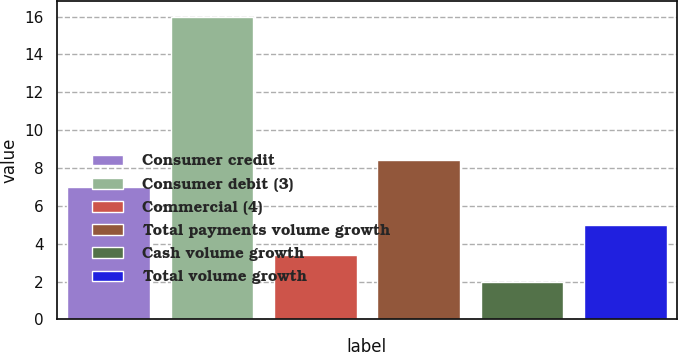<chart> <loc_0><loc_0><loc_500><loc_500><bar_chart><fcel>Consumer credit<fcel>Consumer debit (3)<fcel>Commercial (4)<fcel>Total payments volume growth<fcel>Cash volume growth<fcel>Total volume growth<nl><fcel>7<fcel>16<fcel>3.4<fcel>8.4<fcel>2<fcel>5<nl></chart> 